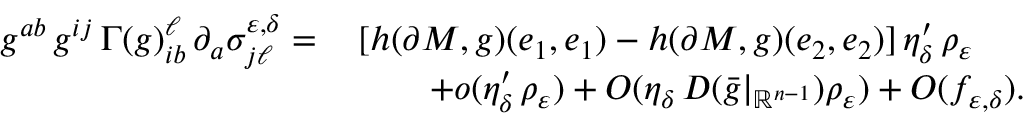<formula> <loc_0><loc_0><loc_500><loc_500>\begin{array} { r l } { g ^ { a b } \, g ^ { i j } \, \Gamma ( g ) _ { i b } ^ { \ell } \, \partial _ { a } \sigma _ { j \ell } ^ { \varepsilon , \delta } = \, } & { [ h ( \partial M , g ) ( e _ { 1 } , e _ { 1 } ) - h ( \partial M , g ) ( e _ { 2 } , e _ { 2 } ) ] \, \eta _ { \delta } ^ { \prime } \, \rho _ { \varepsilon } } \\ & { \quad + o ( \eta _ { \delta } ^ { \prime } \, \rho _ { \varepsilon } ) + O ( \eta _ { \delta } \, D ( \bar { g } | _ { \mathbb { R } ^ { n - 1 } } ) \rho _ { \varepsilon } ) + O ( f _ { \varepsilon , \delta } ) . } \end{array}</formula> 